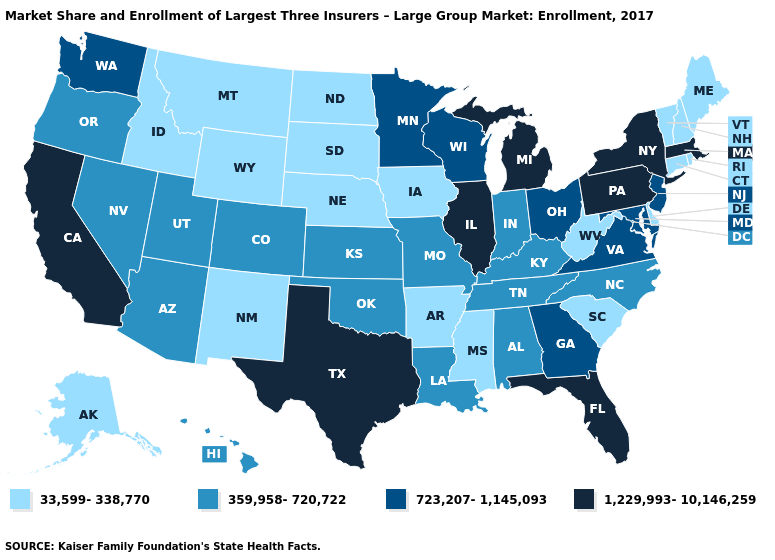What is the value of Hawaii?
Write a very short answer. 359,958-720,722. Which states have the highest value in the USA?
Short answer required. California, Florida, Illinois, Massachusetts, Michigan, New York, Pennsylvania, Texas. Name the states that have a value in the range 359,958-720,722?
Concise answer only. Alabama, Arizona, Colorado, Hawaii, Indiana, Kansas, Kentucky, Louisiana, Missouri, Nevada, North Carolina, Oklahoma, Oregon, Tennessee, Utah. Name the states that have a value in the range 359,958-720,722?
Write a very short answer. Alabama, Arizona, Colorado, Hawaii, Indiana, Kansas, Kentucky, Louisiana, Missouri, Nevada, North Carolina, Oklahoma, Oregon, Tennessee, Utah. What is the lowest value in the USA?
Write a very short answer. 33,599-338,770. Which states have the lowest value in the Northeast?
Quick response, please. Connecticut, Maine, New Hampshire, Rhode Island, Vermont. Among the states that border Pennsylvania , does New York have the highest value?
Be succinct. Yes. Does Montana have the lowest value in the West?
Keep it brief. Yes. What is the value of Montana?
Be succinct. 33,599-338,770. Name the states that have a value in the range 359,958-720,722?
Concise answer only. Alabama, Arizona, Colorado, Hawaii, Indiana, Kansas, Kentucky, Louisiana, Missouri, Nevada, North Carolina, Oklahoma, Oregon, Tennessee, Utah. Name the states that have a value in the range 1,229,993-10,146,259?
Short answer required. California, Florida, Illinois, Massachusetts, Michigan, New York, Pennsylvania, Texas. Name the states that have a value in the range 1,229,993-10,146,259?
Answer briefly. California, Florida, Illinois, Massachusetts, Michigan, New York, Pennsylvania, Texas. Name the states that have a value in the range 33,599-338,770?
Keep it brief. Alaska, Arkansas, Connecticut, Delaware, Idaho, Iowa, Maine, Mississippi, Montana, Nebraska, New Hampshire, New Mexico, North Dakota, Rhode Island, South Carolina, South Dakota, Vermont, West Virginia, Wyoming. Name the states that have a value in the range 1,229,993-10,146,259?
Give a very brief answer. California, Florida, Illinois, Massachusetts, Michigan, New York, Pennsylvania, Texas. Does the first symbol in the legend represent the smallest category?
Be succinct. Yes. 